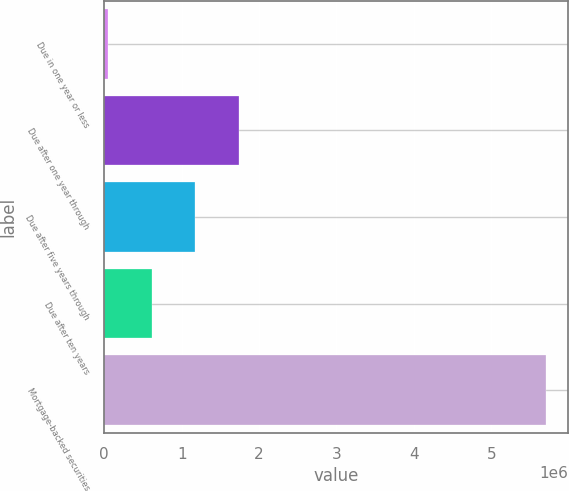<chart> <loc_0><loc_0><loc_500><loc_500><bar_chart><fcel>Due in one year or less<fcel>Due after one year through<fcel>Due after five years through<fcel>Due after ten years<fcel>Mortgage-backed securities<nl><fcel>46646<fcel>1.74392e+06<fcel>1.17816e+06<fcel>612405<fcel>5.70424e+06<nl></chart> 